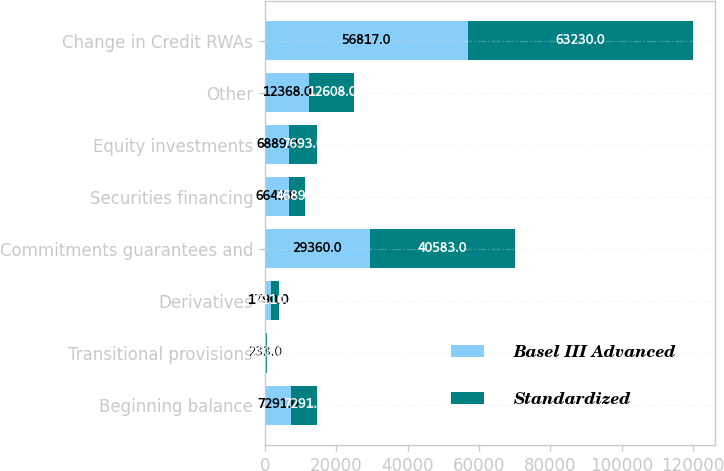Convert chart to OTSL. <chart><loc_0><loc_0><loc_500><loc_500><stacked_bar_chart><ecel><fcel>Beginning balance<fcel>Transitional provisions<fcel>Derivatives<fcel>Commitments guarantees and<fcel>Securities financing<fcel>Equity investments<fcel>Other<fcel>Change in Credit RWAs<nl><fcel>Basel III Advanced<fcel>7291<fcel>233<fcel>1790<fcel>29360<fcel>6643<fcel>6889<fcel>12368<fcel>56817<nl><fcel>Standardized<fcel>7291<fcel>233<fcel>2110<fcel>40583<fcel>4689<fcel>7693<fcel>12608<fcel>63230<nl></chart> 